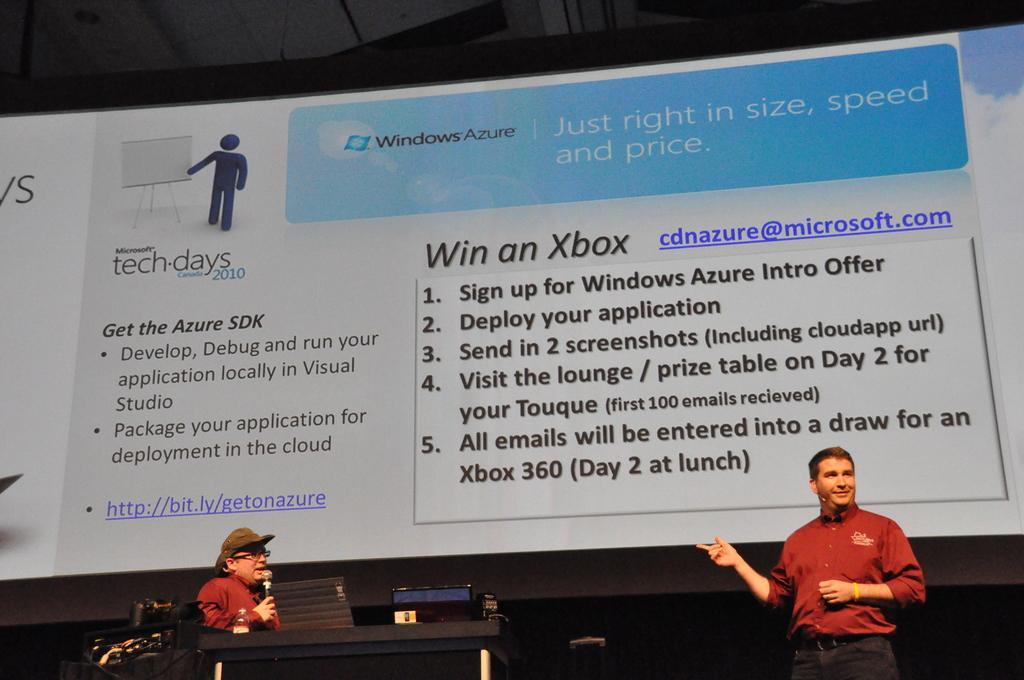In one or two sentences, can you explain what this image depicts? In this picture, there is a board with some text and pictures. At the bottom, there is a man holding a mike and standing before the podium. Towards the bottom right, there is another man wearing a red shirt. 